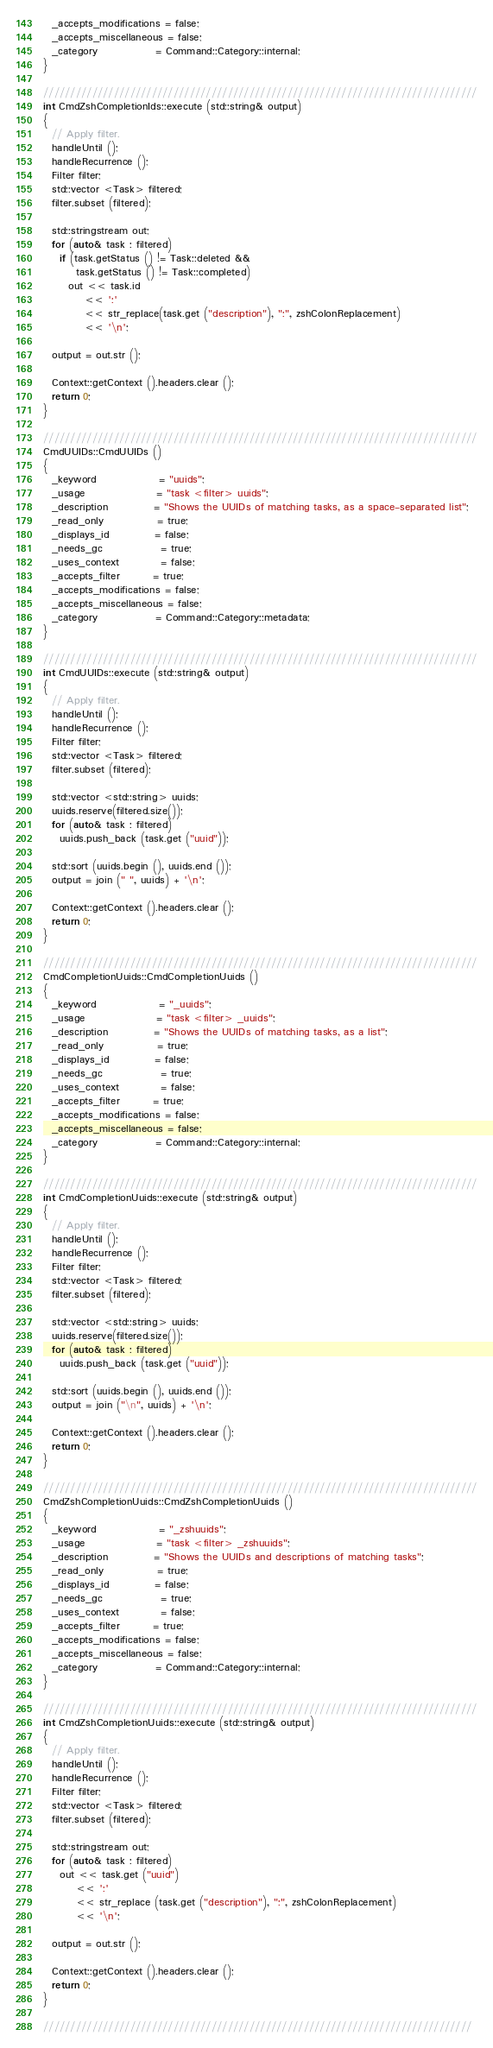Convert code to text. <code><loc_0><loc_0><loc_500><loc_500><_C++_>  _accepts_modifications = false;
  _accepts_miscellaneous = false;
  _category              = Command::Category::internal;
}

////////////////////////////////////////////////////////////////////////////////
int CmdZshCompletionIds::execute (std::string& output)
{
  // Apply filter.
  handleUntil ();
  handleRecurrence ();
  Filter filter;
  std::vector <Task> filtered;
  filter.subset (filtered);

  std::stringstream out;
  for (auto& task : filtered)
    if (task.getStatus () != Task::deleted &&
        task.getStatus () != Task::completed)
      out << task.id
          << ':'
          << str_replace(task.get ("description"), ":", zshColonReplacement)
          << '\n';

  output = out.str ();

  Context::getContext ().headers.clear ();
  return 0;
}

////////////////////////////////////////////////////////////////////////////////
CmdUUIDs::CmdUUIDs ()
{
  _keyword               = "uuids";
  _usage                 = "task <filter> uuids";
  _description           = "Shows the UUIDs of matching tasks, as a space-separated list";
  _read_only             = true;
  _displays_id           = false;
  _needs_gc              = true;
  _uses_context          = false;
  _accepts_filter        = true;
  _accepts_modifications = false;
  _accepts_miscellaneous = false;
  _category              = Command::Category::metadata;
}

////////////////////////////////////////////////////////////////////////////////
int CmdUUIDs::execute (std::string& output)
{
  // Apply filter.
  handleUntil ();
  handleRecurrence ();
  Filter filter;
  std::vector <Task> filtered;
  filter.subset (filtered);

  std::vector <std::string> uuids;
  uuids.reserve(filtered.size());
  for (auto& task : filtered)
    uuids.push_back (task.get ("uuid"));

  std::sort (uuids.begin (), uuids.end ());
  output = join (" ", uuids) + '\n';

  Context::getContext ().headers.clear ();
  return 0;
}

////////////////////////////////////////////////////////////////////////////////
CmdCompletionUuids::CmdCompletionUuids ()
{
  _keyword               = "_uuids";
  _usage                 = "task <filter> _uuids";
  _description           = "Shows the UUIDs of matching tasks, as a list";
  _read_only             = true;
  _displays_id           = false;
  _needs_gc              = true;
  _uses_context          = false;
  _accepts_filter        = true;
  _accepts_modifications = false;
  _accepts_miscellaneous = false;
  _category              = Command::Category::internal;
}

////////////////////////////////////////////////////////////////////////////////
int CmdCompletionUuids::execute (std::string& output)
{
  // Apply filter.
  handleUntil ();
  handleRecurrence ();
  Filter filter;
  std::vector <Task> filtered;
  filter.subset (filtered);

  std::vector <std::string> uuids;
  uuids.reserve(filtered.size());
  for (auto& task : filtered)
    uuids.push_back (task.get ("uuid"));

  std::sort (uuids.begin (), uuids.end ());
  output = join ("\n", uuids) + '\n';

  Context::getContext ().headers.clear ();
  return 0;
}

////////////////////////////////////////////////////////////////////////////////
CmdZshCompletionUuids::CmdZshCompletionUuids ()
{
  _keyword               = "_zshuuids";
  _usage                 = "task <filter> _zshuuids";
  _description           = "Shows the UUIDs and descriptions of matching tasks";
  _read_only             = true;
  _displays_id           = false;
  _needs_gc              = true;
  _uses_context          = false;
  _accepts_filter        = true;
  _accepts_modifications = false;
  _accepts_miscellaneous = false;
  _category              = Command::Category::internal;
}

////////////////////////////////////////////////////////////////////////////////
int CmdZshCompletionUuids::execute (std::string& output)
{
  // Apply filter.
  handleUntil ();
  handleRecurrence ();
  Filter filter;
  std::vector <Task> filtered;
  filter.subset (filtered);

  std::stringstream out;
  for (auto& task : filtered)
    out << task.get ("uuid")
        << ':'
        << str_replace (task.get ("description"), ":", zshColonReplacement)
        << '\n';

  output = out.str ();

  Context::getContext ().headers.clear ();
  return 0;
}

///////////////////////////////////////////////////////////////////////////////
</code> 